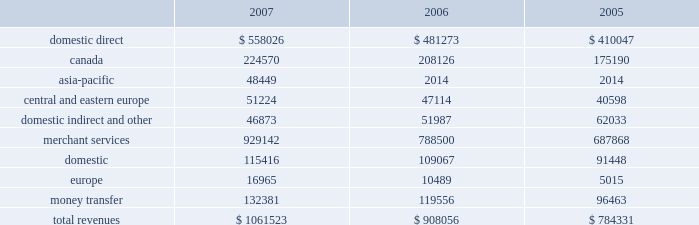Asia-pacific acquisition on july 24 , 2006 , we completed the purchase of a fifty-six percent ownership interest in the merchant acquiring business of the hongkong and shanghai banking corporation limited , or hsbc .
This business provides card payment processing services to merchants in the asia-pacific region .
The business includes hsbc 2019s payment processing operations in the following ten countries and territories : brunei , china , hong kong , india , macau , malaysia , maldives , singapore , sri lanka and taiwan .
Under the terms of the agreement , we initially paid hsbc $ 67.2 million in cash to acquire our ownership interest .
We paid an additional $ 1.4 million under this agreement during fiscal 2007 , for a total purchase price of $ 68.6 million to acquire our ownership interest .
In conjunction with this acquisition , we entered into a transition services agreement with hsbc that may be terminated at any time .
Under this agreement , we expect hsbc will continue to perform payment processing operations and related support services until we integrate these functions into our own operations , which we expect will be completed in 2010 .
The operating results of this acquisition are included in our consolidated statements of income from the date of the acquisition .
Business description we are a leading payment processing and consumer money transfer company .
As a high-volume processor of electronic transactions , we enable merchants , multinational corporations , financial institutions , consumers , government agencies and other profit and non-profit business enterprises to facilitate payments to purchase goods and services or further other economic goals .
Our role is to serve as an intermediary in the exchange of information and funds that must occur between parties so that a payment transaction or money transfer can be completed .
We were incorporated in georgia as global payments inc .
In september 2000 , and we spun-off from our former parent company on january 31 , 2001 .
Including our time as part of our former parent company , we have provided transaction processing services since 1967 .
We market our products and services throughout the united states , canada , europe and the asia-pacific region .
We operate in two business segments , merchant services and money transfer , and we offer various products through these segments .
Our merchant services segment targets customers in many vertical industries including financial institutions , gaming , government , health care , professional services , restaurants , retail , universities and utilities .
Our money transfer segment primarily targets immigrants in the united states and europe .
See note 10 in the notes to consolidated financial statements for additional segment information and 201citem 1a 2014risk factors 201d for a discussion of risks involved with our international operations .
Total revenues from our merchant services and money transfer segments , by geography and sales channel , are as follows ( amounts in thousands ) : .

What percent of total revenues was represented by merchant services in 2007? 
Computations: (929142 / 1061523)
Answer: 0.87529. 